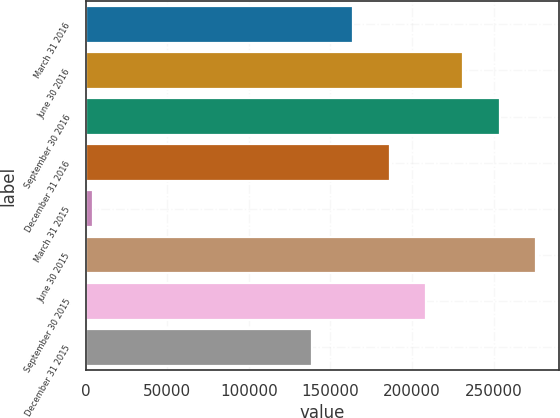Convert chart to OTSL. <chart><loc_0><loc_0><loc_500><loc_500><bar_chart><fcel>March 31 2016<fcel>June 30 2016<fcel>September 30 2016<fcel>December 31 2016<fcel>March 31 2015<fcel>June 30 2015<fcel>September 30 2015<fcel>December 31 2015<nl><fcel>163877<fcel>231254<fcel>253713<fcel>186336<fcel>4414<fcel>276172<fcel>208795<fcel>138741<nl></chart> 